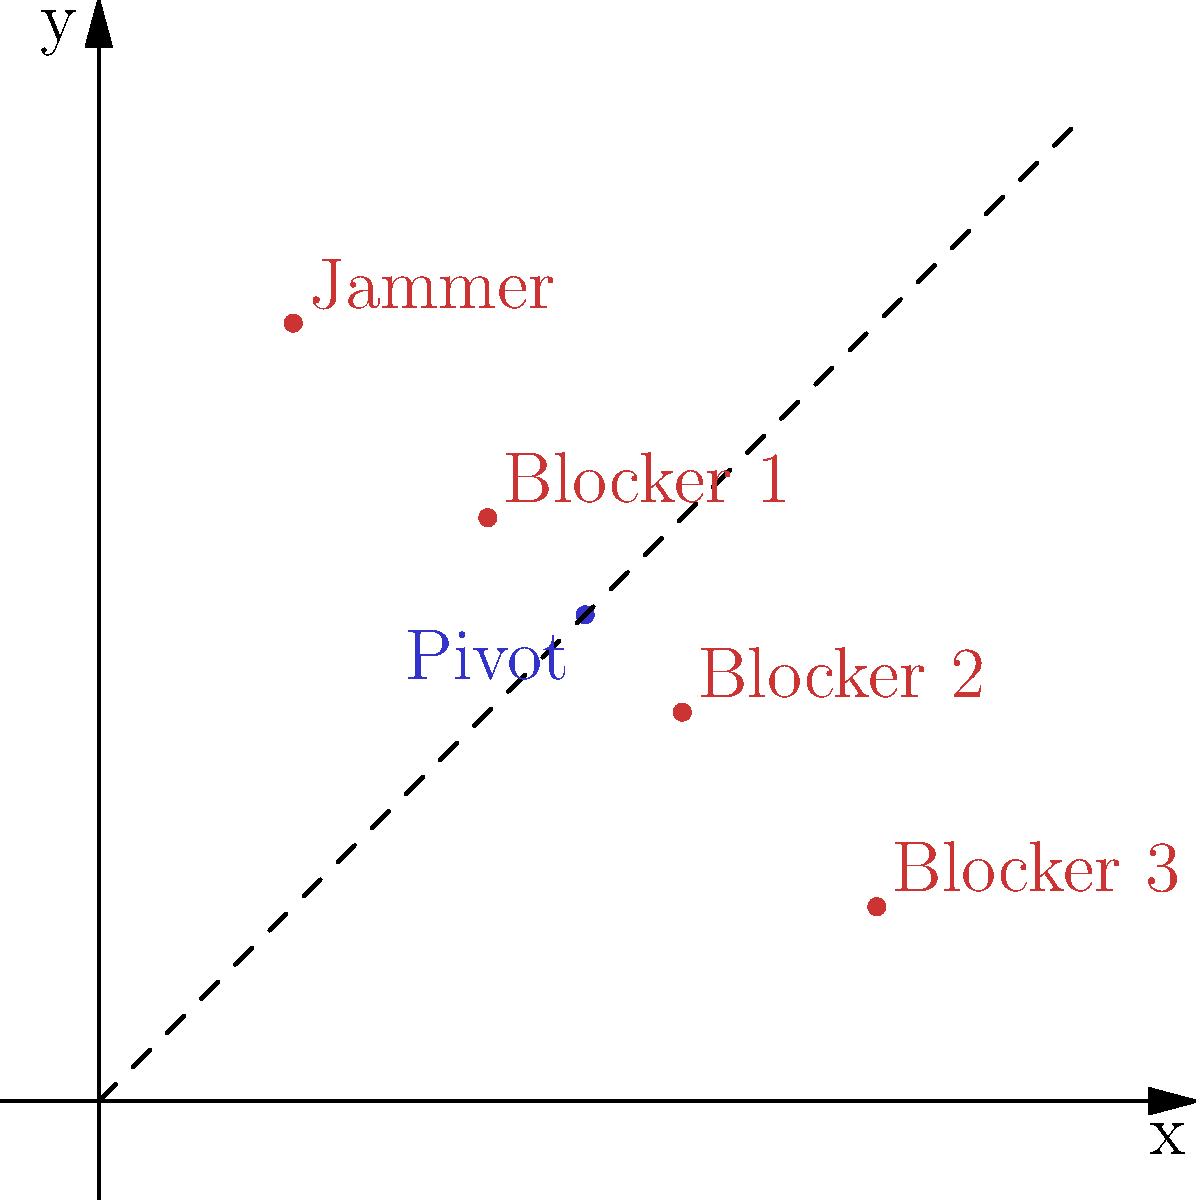In a roller derby match, the team's formation is visualized on a coordinate system representing the rectangular rink. The jammer is positioned at (20, 80), three blockers are at (40, 60), (60, 40), and (80, 20), while the pivot is at (50, 50). What geometric shape best describes the overall team formation, and what is its significance in roller derby strategy? To determine the geometric shape of the team formation and its strategic significance, let's analyze the positions step-by-step:

1. Plot the positions:
   - Jammer: (20, 80)
   - Blocker 1: (40, 60)
   - Blocker 2: (60, 40)
   - Blocker 3: (80, 20)
   - Pivot: (50, 50)

2. Observe the pattern:
   - The four players (excluding the pivot) form a straight line.
   - This line can be described by the equation $y = -x + 100$.

3. Identify the shape:
   - The formation creates a diamond shape with the pivot at the center.
   - The jammer and Blocker 3 form two opposite vertices of the diamond.
   - Blockers 1 and 2 form the other two vertices.

4. Analyze the strategic significance:
   - The diamond formation allows for flexible defense and offense.
   - The pivot at the center can quickly move to support any position.
   - The linear arrangement of the other players creates a diagonal "wall" across the track.
   - This formation can effectively block opponents while creating openings for the jammer.

5. Consider the coordinate system representation:
   - The diagonal line (y = -x + 100) bisects the rink, maximizing track coverage.
   - The even spacing between players (20 units) allows for consistent support and communication.

Therefore, the geometric shape best describing the team formation is a diamond, with strategic significance in its versatility for both offensive and defensive play in roller derby.
Answer: Diamond formation; versatile for offense and defense 